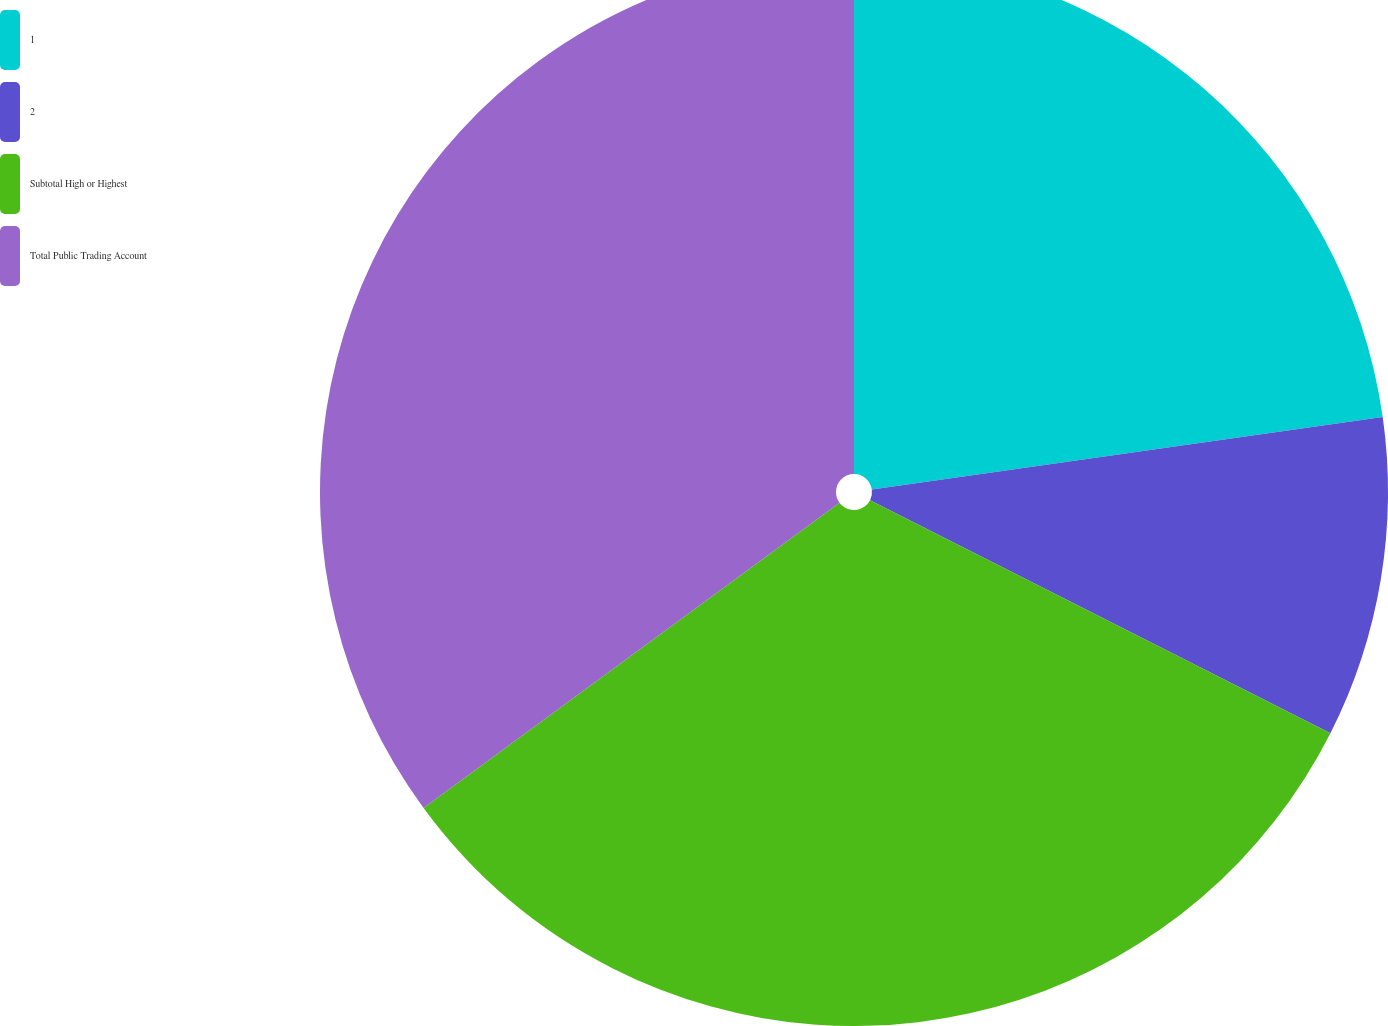Convert chart. <chart><loc_0><loc_0><loc_500><loc_500><pie_chart><fcel>1<fcel>2<fcel>Subtotal High or Highest<fcel>Total Public Trading Account<nl><fcel>22.76%<fcel>9.7%<fcel>32.46%<fcel>35.08%<nl></chart> 